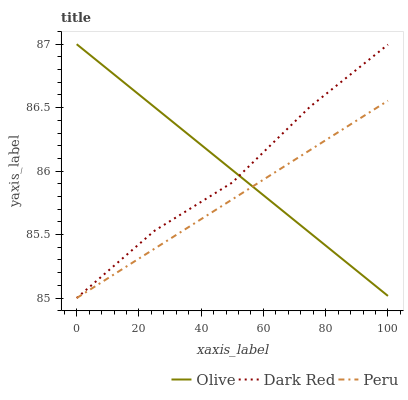Does Peru have the minimum area under the curve?
Answer yes or no. Yes. Does Olive have the maximum area under the curve?
Answer yes or no. Yes. Does Dark Red have the minimum area under the curve?
Answer yes or no. No. Does Dark Red have the maximum area under the curve?
Answer yes or no. No. Is Olive the smoothest?
Answer yes or no. Yes. Is Dark Red the roughest?
Answer yes or no. Yes. Is Peru the smoothest?
Answer yes or no. No. Is Peru the roughest?
Answer yes or no. No. Does Dark Red have the lowest value?
Answer yes or no. Yes. Does Olive have the highest value?
Answer yes or no. Yes. Does Dark Red have the highest value?
Answer yes or no. No. Does Olive intersect Peru?
Answer yes or no. Yes. Is Olive less than Peru?
Answer yes or no. No. Is Olive greater than Peru?
Answer yes or no. No. 